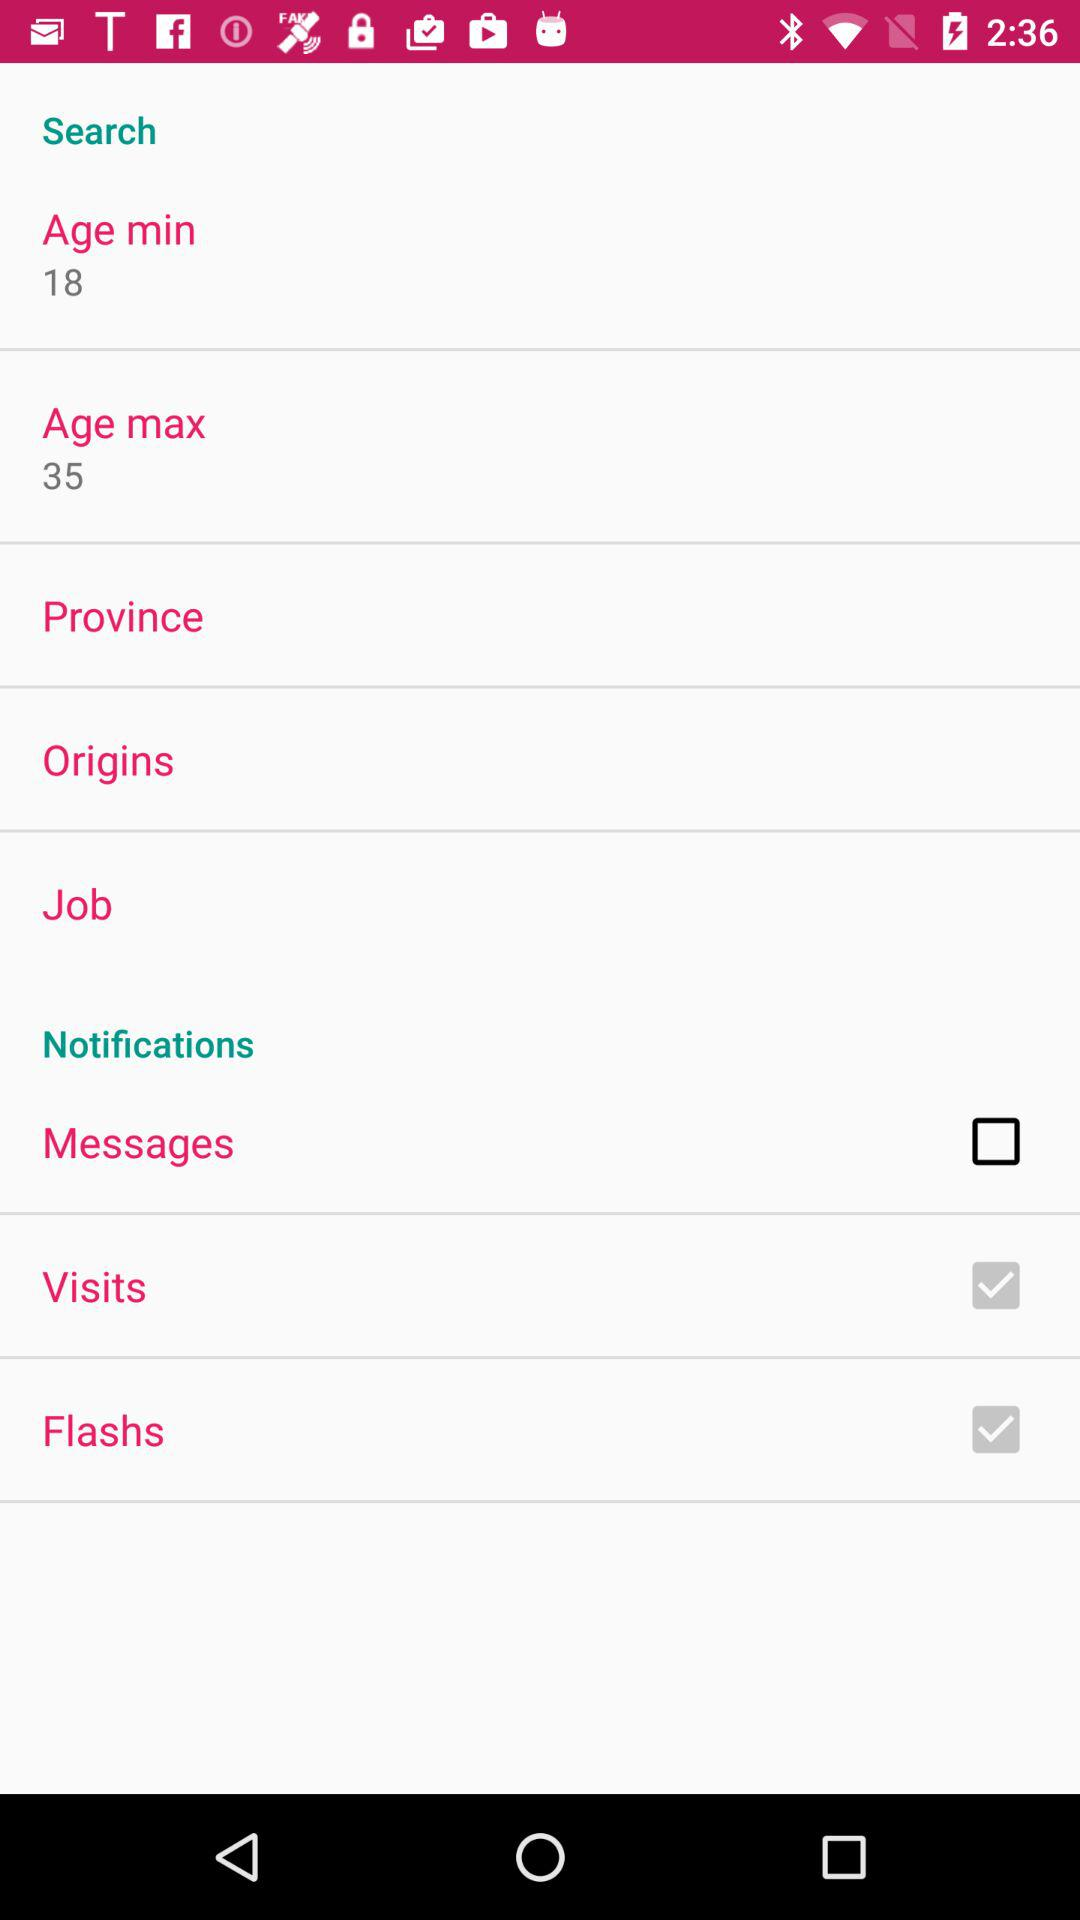What are the setting options for "Notifications"? The setting options are "Messages", "Visits" and "Flashs". 